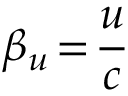<formula> <loc_0><loc_0><loc_500><loc_500>\beta _ { u } \, = \, \frac { u } { c }</formula> 